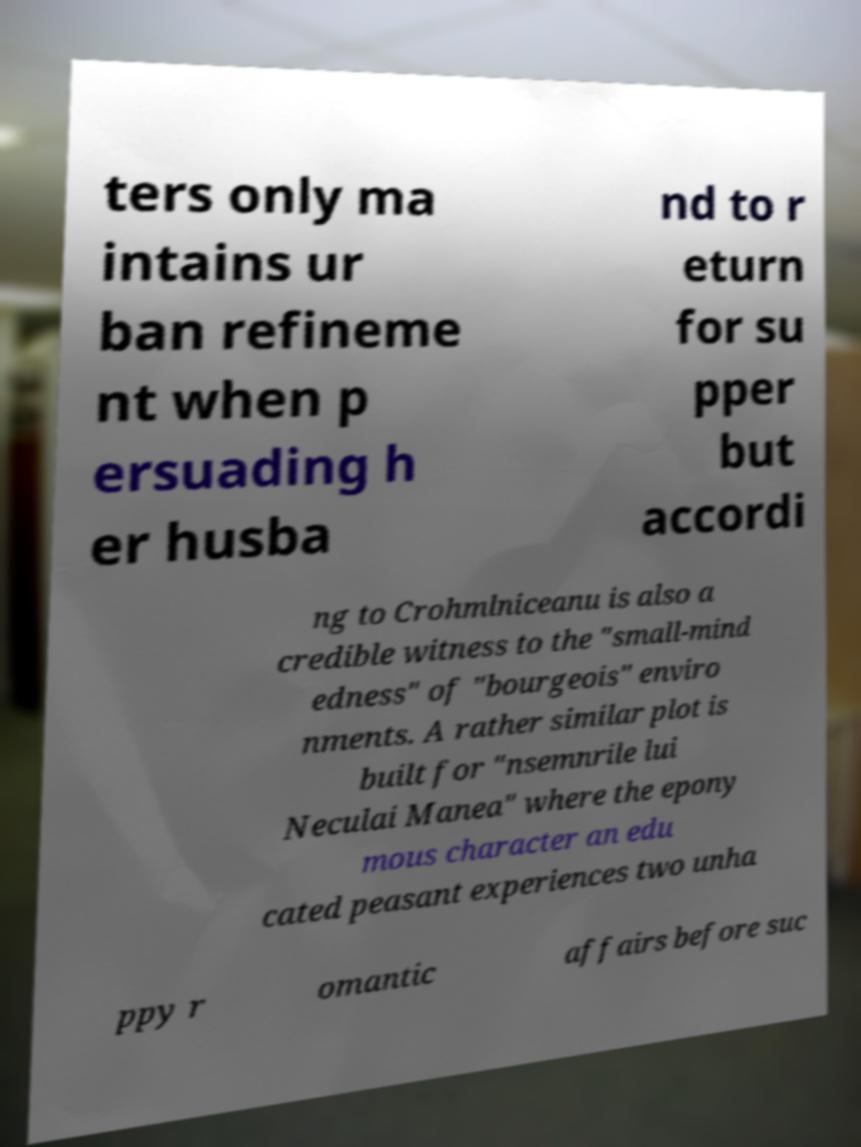Please read and relay the text visible in this image. What does it say? ters only ma intains ur ban refineme nt when p ersuading h er husba nd to r eturn for su pper but accordi ng to Crohmlniceanu is also a credible witness to the "small-mind edness" of "bourgeois" enviro nments. A rather similar plot is built for "nsemnrile lui Neculai Manea" where the epony mous character an edu cated peasant experiences two unha ppy r omantic affairs before suc 